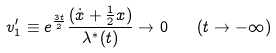Convert formula to latex. <formula><loc_0><loc_0><loc_500><loc_500>v _ { 1 } ^ { \prime } \equiv e ^ { \frac { 3 t } { 2 } } { \frac { ( { \dot { x } } + { \frac { 1 } { 2 } } x ) } { \lambda ^ { * } ( t ) } } \rightarrow 0 \quad ( t \rightarrow - \infty )</formula> 